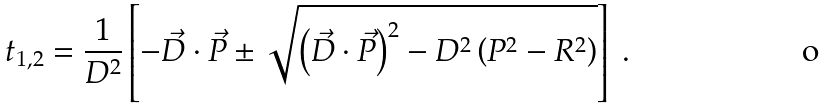Convert formula to latex. <formula><loc_0><loc_0><loc_500><loc_500>t _ { 1 , 2 } = \frac { 1 } { D ^ { 2 } } \left [ - \vec { D } \cdot \vec { P } \pm \sqrt { \left ( \vec { D } \cdot \vec { P } \right ) ^ { 2 } - D ^ { 2 } \left ( P ^ { 2 } - R ^ { 2 } \right ) } \right ] \ .</formula> 